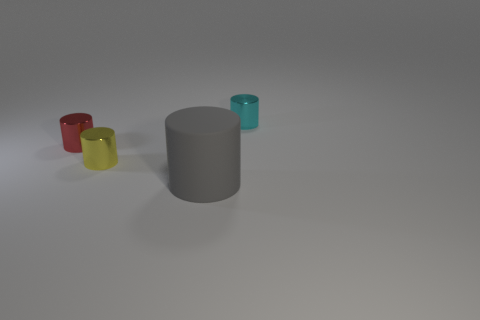Are there fewer big gray objects that are in front of the small red shiny thing than big matte cylinders?
Ensure brevity in your answer.  No. What size is the rubber thing that is in front of the yellow cylinder?
Ensure brevity in your answer.  Large. There is a thing that is in front of the red metal cylinder and on the left side of the large gray cylinder; what is its shape?
Offer a terse response. Cylinder. Is there a cyan metallic cylinder that has the same size as the yellow thing?
Your response must be concise. Yes. Are there any red shiny objects that have the same shape as the yellow shiny thing?
Offer a terse response. Yes. There is a tiny thing that is on the left side of the small thing in front of the red thing; what is its shape?
Your answer should be very brief. Cylinder. There is a thing on the right side of the rubber thing; what color is it?
Offer a terse response. Cyan. What size is the yellow thing that is the same shape as the red object?
Give a very brief answer. Small. Are there any cyan rubber objects?
Your answer should be very brief. No. What number of things are metal objects on the right side of the gray rubber thing or tiny red metallic objects?
Keep it short and to the point. 2. 